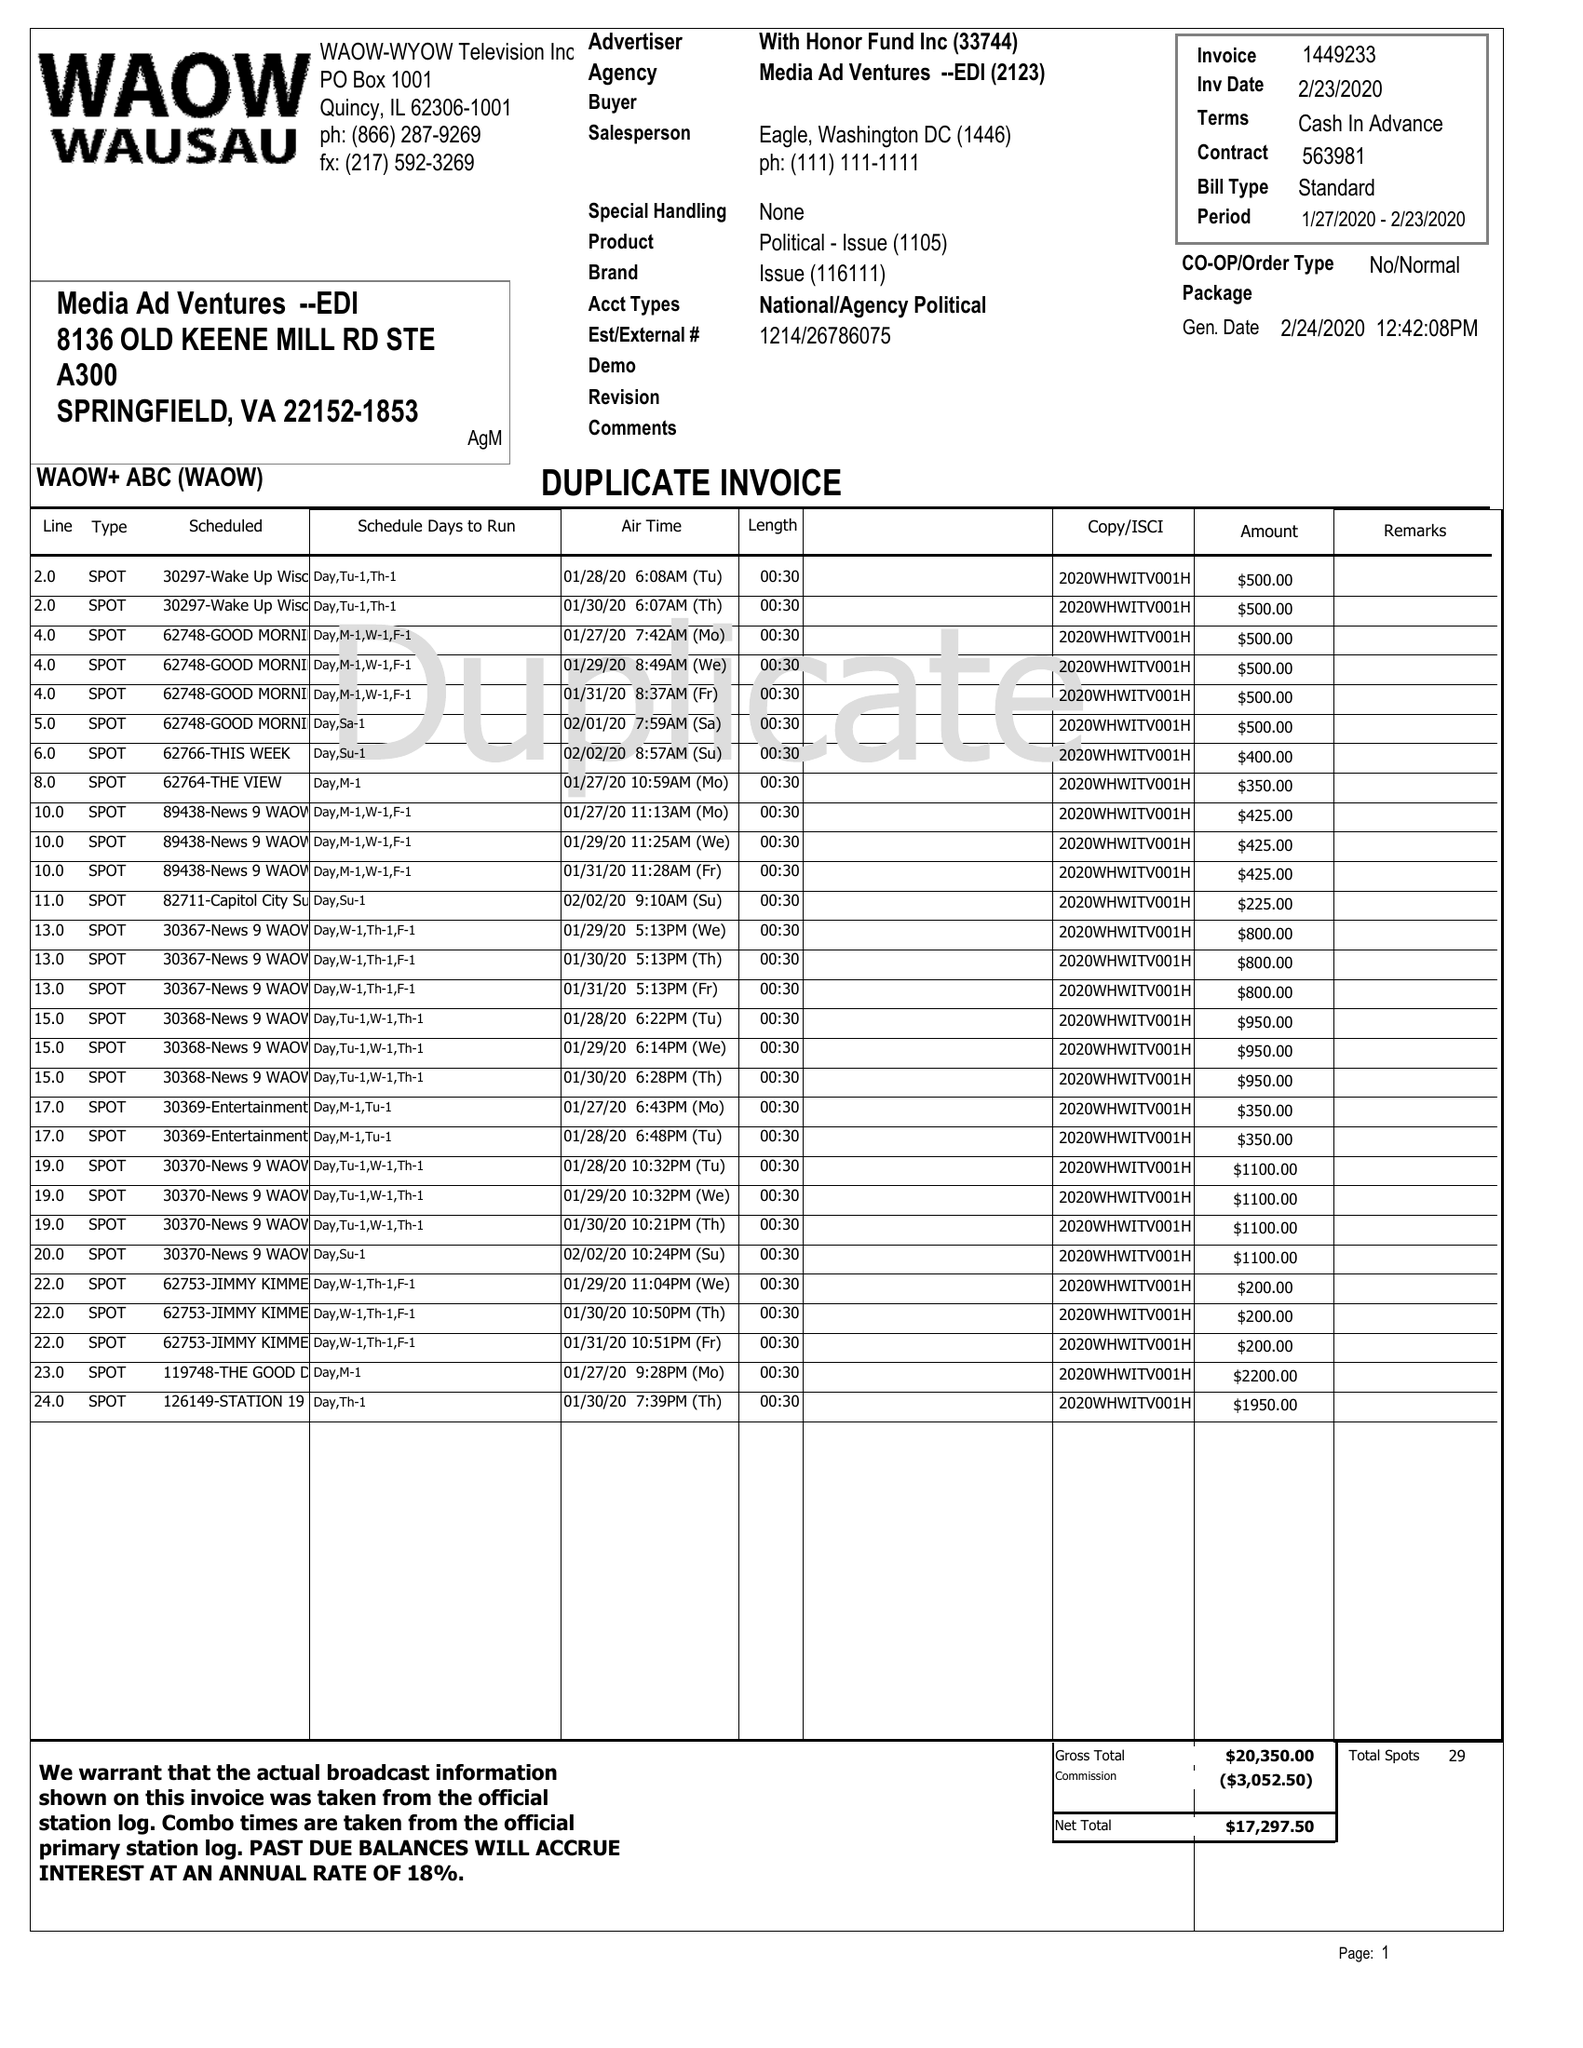What is the value for the flight_to?
Answer the question using a single word or phrase. 02/23/20 